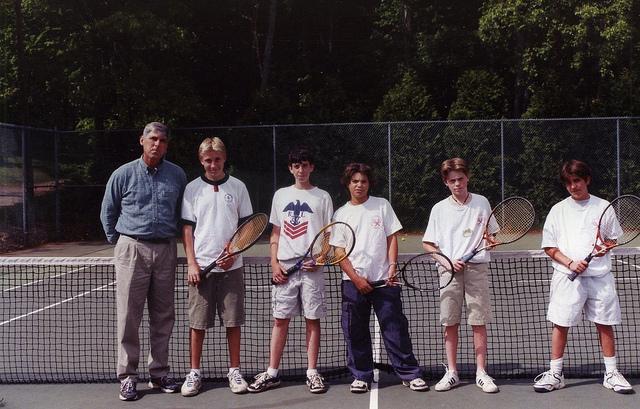What sport do they play?
Keep it brief. Tennis. What color is the court?
Write a very short answer. Gray. What is the color of the object in the back on the grass?
Short answer required. Green. 